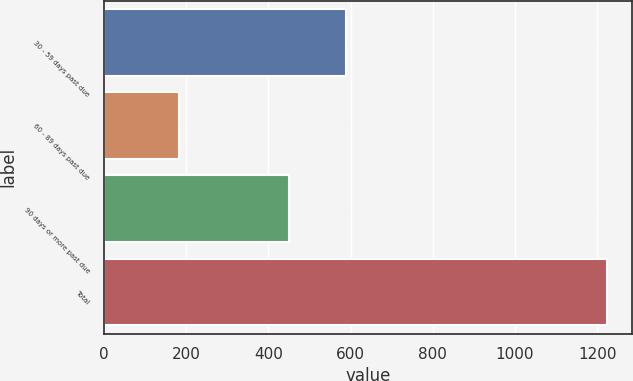Convert chart to OTSL. <chart><loc_0><loc_0><loc_500><loc_500><bar_chart><fcel>30 - 59 days past due<fcel>60 - 89 days past due<fcel>90 days or more past due<fcel>Total<nl><fcel>590<fcel>183<fcel>450<fcel>1223<nl></chart> 